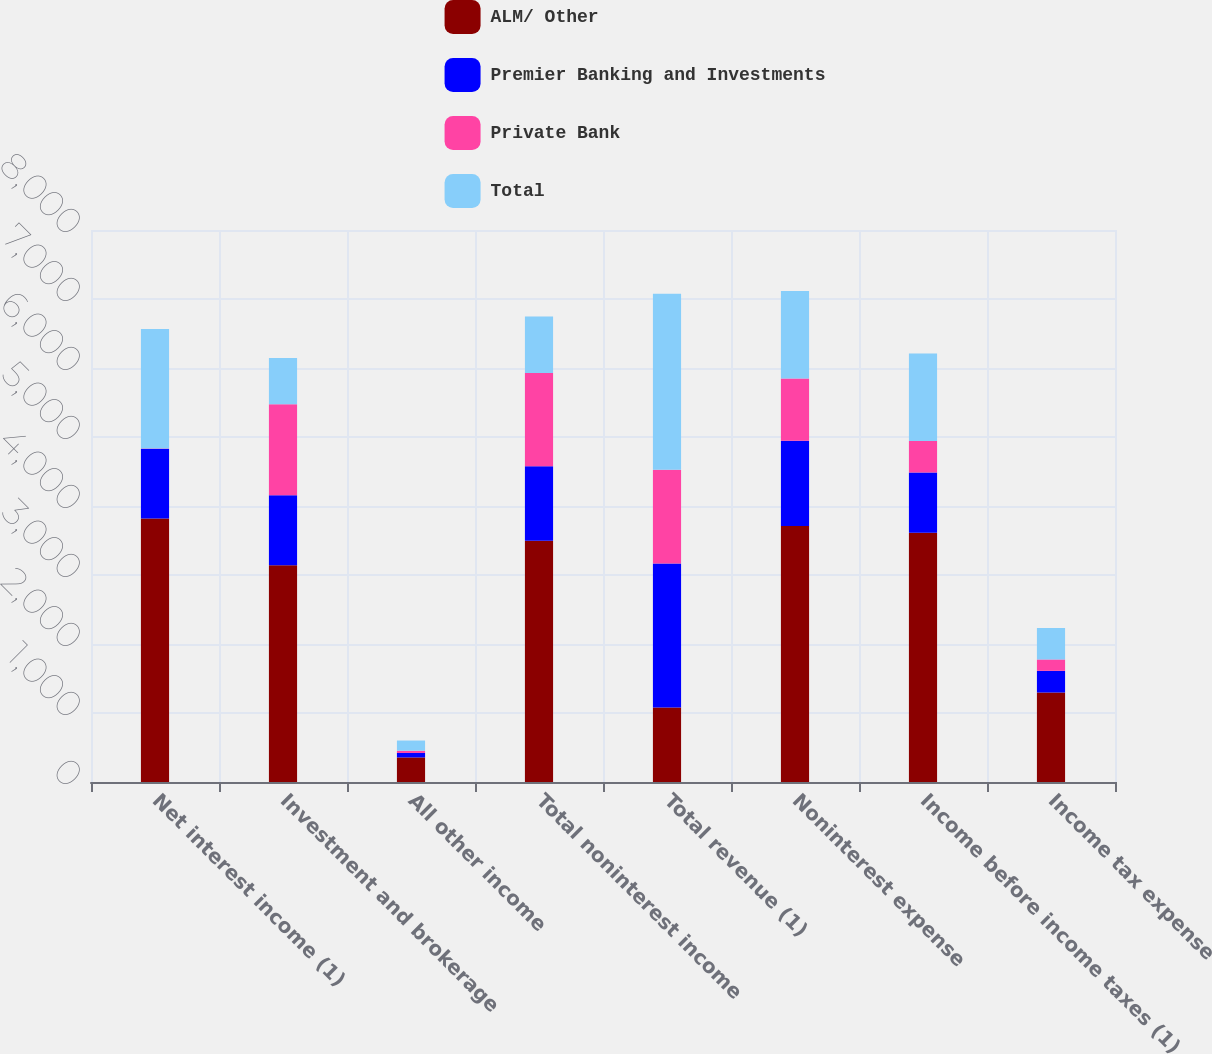<chart> <loc_0><loc_0><loc_500><loc_500><stacked_bar_chart><ecel><fcel>Net interest income (1)<fcel>Investment and brokerage<fcel>All other income<fcel>Total noninterest income<fcel>Total revenue (1)<fcel>Noninterest expense<fcel>Income before income taxes (1)<fcel>Income tax expense<nl><fcel>ALM/ Other<fcel>3820<fcel>3140<fcel>356<fcel>3496<fcel>1079<fcel>3710<fcel>3613<fcel>1297<nl><fcel>Premier Banking and Investments<fcel>1008<fcel>1014<fcel>65<fcel>1079<fcel>2087<fcel>1237<fcel>873<fcel>314<nl><fcel>Private Bank<fcel>6<fcel>1321<fcel>32<fcel>1353<fcel>1359<fcel>902<fcel>457<fcel>165<nl><fcel>Total<fcel>1732<fcel>670<fcel>148<fcel>818<fcel>2550<fcel>1266<fcel>1266<fcel>456<nl></chart> 